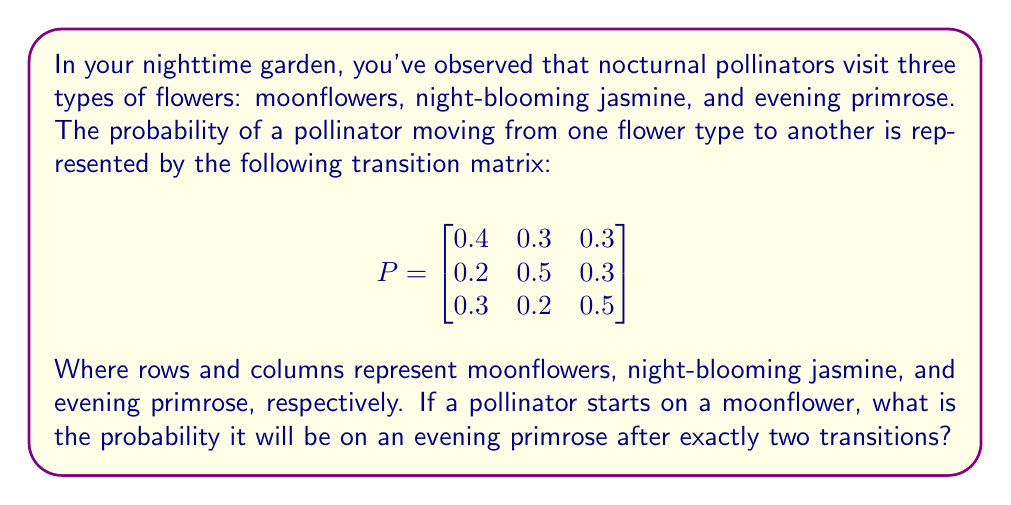Can you answer this question? To solve this problem, we need to use the properties of Markov chains and matrix multiplication. Let's break it down step-by-step:

1) The initial state vector, given that the pollinator starts on a moonflower, is:

   $$v_0 = \begin{bmatrix} 1 & 0 & 0 \end{bmatrix}$$

2) To find the probability distribution after two transitions, we need to multiply the initial state vector by the transition matrix twice:

   $$v_2 = v_0 \cdot P^2$$

3) Let's calculate $P^2$:

   $$
   P^2 = P \cdot P = \begin{bmatrix}
   0.4 & 0.3 & 0.3 \\
   0.2 & 0.5 & 0.3 \\
   0.3 & 0.2 & 0.5
   \end{bmatrix} \cdot 
   \begin{bmatrix}
   0.4 & 0.3 & 0.3 \\
   0.2 & 0.5 & 0.3 \\
   0.3 & 0.2 & 0.5
   \end{bmatrix}
   $$

4) Performing the matrix multiplication:

   $$
   P^2 = \begin{bmatrix}
   0.31 & 0.33 & 0.36 \\
   0.29 & 0.38 & 0.33 \\
   0.31 & 0.28 & 0.41
   \end{bmatrix}
   $$

5) Now, we multiply $v_0$ by $P^2$:

   $$v_2 = \begin{bmatrix} 1 & 0 & 0 \end{bmatrix} \cdot 
   \begin{bmatrix}
   0.31 & 0.33 & 0.36 \\
   0.29 & 0.38 & 0.33 \\
   0.31 & 0.28 & 0.41
   \end{bmatrix}$$

6) This multiplication results in:

   $$v_2 = \begin{bmatrix} 0.31 & 0.33 & 0.36 \end{bmatrix}$$

7) The probability of being on an evening primrose (the third element) after two transitions is 0.36 or 36%.
Answer: 0.36 